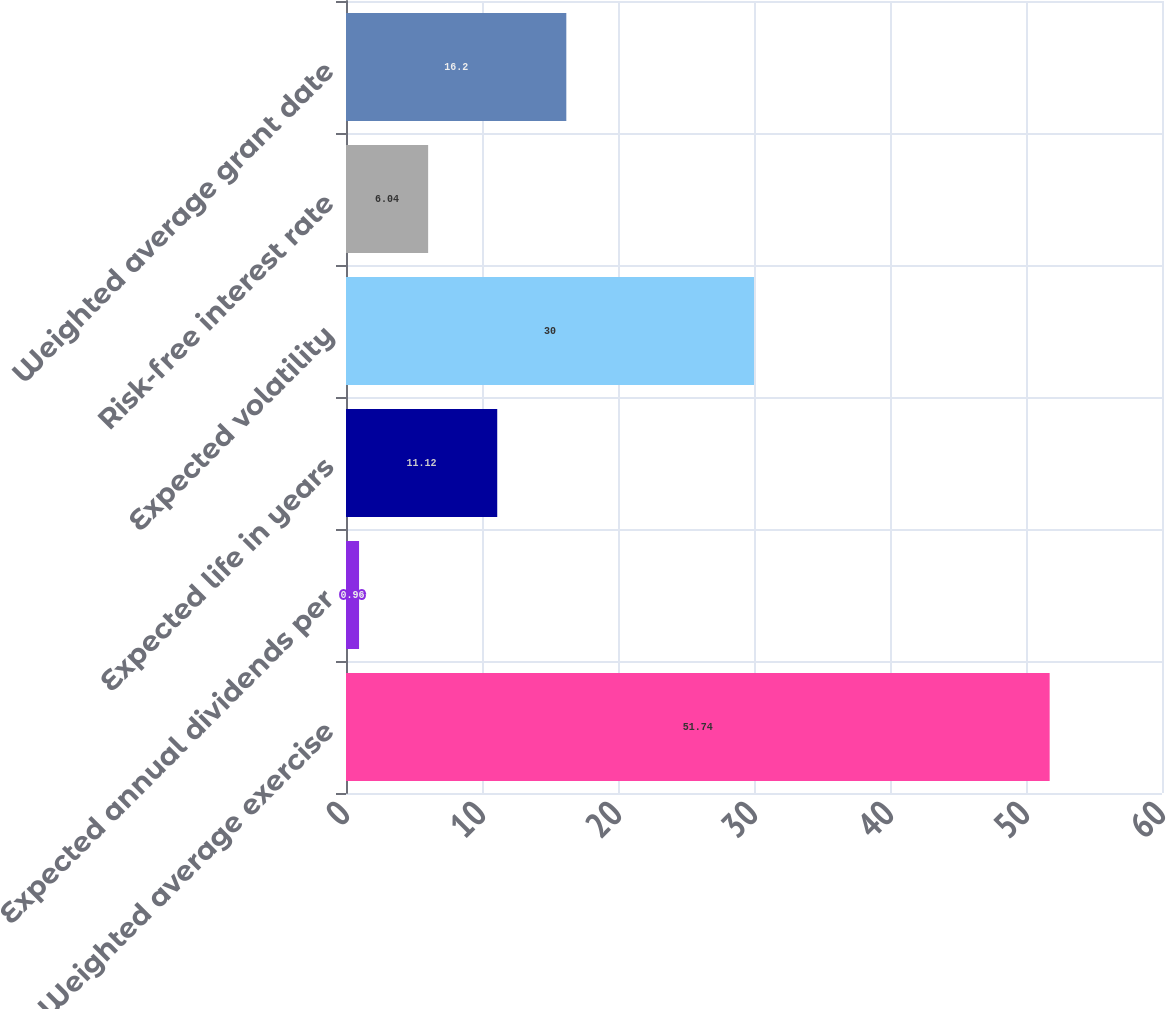Convert chart to OTSL. <chart><loc_0><loc_0><loc_500><loc_500><bar_chart><fcel>Weighted average exercise<fcel>Expected annual dividends per<fcel>Expected life in years<fcel>Expected volatility<fcel>Risk-free interest rate<fcel>Weighted average grant date<nl><fcel>51.74<fcel>0.96<fcel>11.12<fcel>30<fcel>6.04<fcel>16.2<nl></chart> 